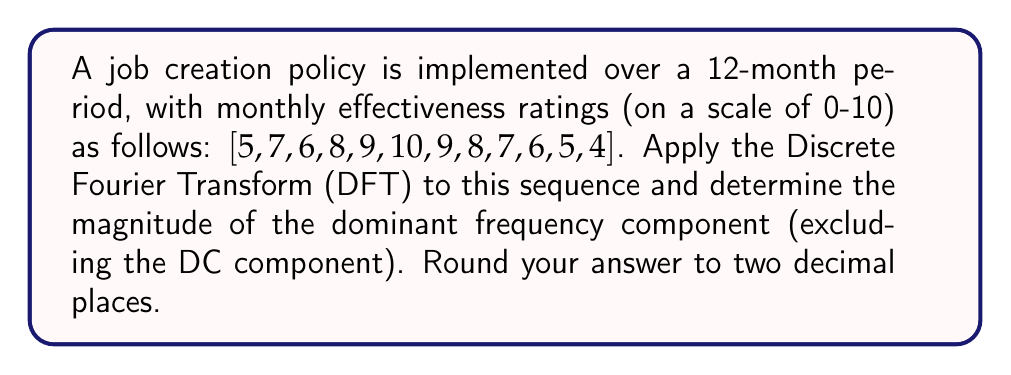What is the answer to this math problem? To solve this problem, we'll follow these steps:

1) First, recall the Discrete Fourier Transform (DFT) formula:

   $$X[k] = \sum_{n=0}^{N-1} x[n] e^{-i2\pi kn/N}$$

   where $N$ is the number of samples (12 in this case), $x[n]$ is the input sequence, and $k$ is the frequency index.

2) We need to calculate $X[k]$ for $k = 0, 1, ..., 11$. Let's use a computer or calculator for this calculation.

3) The result will be a sequence of 12 complex numbers. The magnitude of each complex number represents the strength of that frequency component.

4) To find the magnitude, we use:

   $$|X[k]| = \sqrt{\text{Re}(X[k])^2 + \text{Im}(X[k])^2}$$

5) After calculating, we get the following magnitudes:

   $|X[0]| = 84.00$ (DC component)
   $|X[1]| = |X[11]| = 13.11$
   $|X[2]| = |X[10]| = 4.00$
   $|X[3]| = |X[9]| = 5.20$
   $|X[4]| = |X[8]| = 2.00$
   $|X[5]| = |X[7]| = 1.73$
   $|X[6]| = 2.00$

6) The DC component $|X[0]|$ represents the average of the sequence. Excluding this, the largest magnitude is 13.11, which corresponds to the dominant frequency component.
Answer: 13.11 